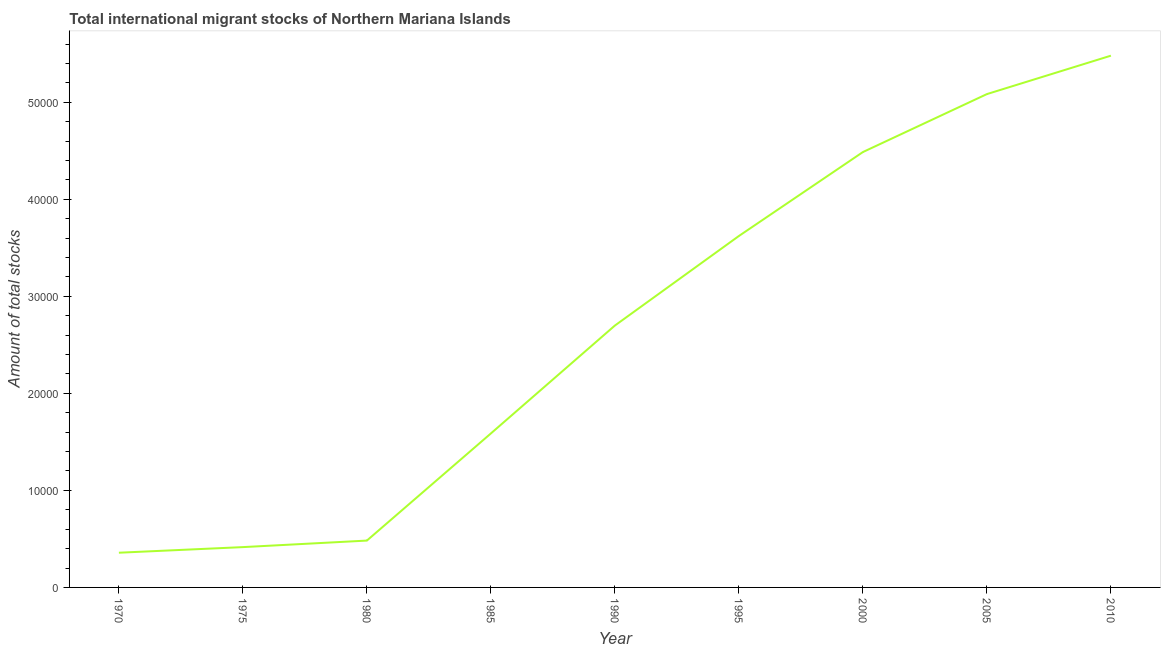What is the total number of international migrant stock in 2005?
Your response must be concise. 5.08e+04. Across all years, what is the maximum total number of international migrant stock?
Give a very brief answer. 5.48e+04. Across all years, what is the minimum total number of international migrant stock?
Your response must be concise. 3576. In which year was the total number of international migrant stock maximum?
Give a very brief answer. 2010. In which year was the total number of international migrant stock minimum?
Ensure brevity in your answer.  1970. What is the sum of the total number of international migrant stock?
Ensure brevity in your answer.  2.42e+05. What is the difference between the total number of international migrant stock in 1980 and 1985?
Your answer should be very brief. -1.10e+04. What is the average total number of international migrant stock per year?
Offer a very short reply. 2.69e+04. What is the median total number of international migrant stock?
Give a very brief answer. 2.70e+04. In how many years, is the total number of international migrant stock greater than 36000 ?
Keep it short and to the point. 4. What is the ratio of the total number of international migrant stock in 1980 to that in 2005?
Offer a very short reply. 0.09. Is the total number of international migrant stock in 1975 less than that in 1980?
Ensure brevity in your answer.  Yes. Is the difference between the total number of international migrant stock in 1995 and 2005 greater than the difference between any two years?
Your answer should be compact. No. What is the difference between the highest and the second highest total number of international migrant stock?
Keep it short and to the point. 3959. What is the difference between the highest and the lowest total number of international migrant stock?
Your response must be concise. 5.12e+04. How many lines are there?
Offer a terse response. 1. How many years are there in the graph?
Offer a terse response. 9. Does the graph contain any zero values?
Give a very brief answer. No. What is the title of the graph?
Your response must be concise. Total international migrant stocks of Northern Mariana Islands. What is the label or title of the Y-axis?
Your answer should be very brief. Amount of total stocks. What is the Amount of total stocks in 1970?
Offer a very short reply. 3576. What is the Amount of total stocks of 1975?
Make the answer very short. 4155. What is the Amount of total stocks in 1980?
Your answer should be compact. 4828. What is the Amount of total stocks in 1985?
Your answer should be compact. 1.59e+04. What is the Amount of total stocks in 1990?
Provide a succinct answer. 2.70e+04. What is the Amount of total stocks of 1995?
Offer a terse response. 3.62e+04. What is the Amount of total stocks in 2000?
Give a very brief answer. 4.49e+04. What is the Amount of total stocks of 2005?
Give a very brief answer. 5.08e+04. What is the Amount of total stocks of 2010?
Offer a terse response. 5.48e+04. What is the difference between the Amount of total stocks in 1970 and 1975?
Keep it short and to the point. -579. What is the difference between the Amount of total stocks in 1970 and 1980?
Offer a terse response. -1252. What is the difference between the Amount of total stocks in 1970 and 1985?
Ensure brevity in your answer.  -1.23e+04. What is the difference between the Amount of total stocks in 1970 and 1990?
Your response must be concise. -2.34e+04. What is the difference between the Amount of total stocks in 1970 and 1995?
Provide a succinct answer. -3.26e+04. What is the difference between the Amount of total stocks in 1970 and 2000?
Keep it short and to the point. -4.13e+04. What is the difference between the Amount of total stocks in 1970 and 2005?
Offer a terse response. -4.73e+04. What is the difference between the Amount of total stocks in 1970 and 2010?
Ensure brevity in your answer.  -5.12e+04. What is the difference between the Amount of total stocks in 1975 and 1980?
Provide a succinct answer. -673. What is the difference between the Amount of total stocks in 1975 and 1985?
Make the answer very short. -1.17e+04. What is the difference between the Amount of total stocks in 1975 and 1990?
Give a very brief answer. -2.28e+04. What is the difference between the Amount of total stocks in 1975 and 1995?
Keep it short and to the point. -3.21e+04. What is the difference between the Amount of total stocks in 1975 and 2000?
Make the answer very short. -4.07e+04. What is the difference between the Amount of total stocks in 1975 and 2005?
Your answer should be very brief. -4.67e+04. What is the difference between the Amount of total stocks in 1975 and 2010?
Provide a succinct answer. -5.06e+04. What is the difference between the Amount of total stocks in 1980 and 1985?
Provide a short and direct response. -1.10e+04. What is the difference between the Amount of total stocks in 1980 and 1990?
Offer a very short reply. -2.22e+04. What is the difference between the Amount of total stocks in 1980 and 1995?
Give a very brief answer. -3.14e+04. What is the difference between the Amount of total stocks in 1980 and 2000?
Offer a very short reply. -4.00e+04. What is the difference between the Amount of total stocks in 1980 and 2005?
Your answer should be compact. -4.60e+04. What is the difference between the Amount of total stocks in 1980 and 2010?
Provide a short and direct response. -5.00e+04. What is the difference between the Amount of total stocks in 1985 and 1990?
Offer a very short reply. -1.11e+04. What is the difference between the Amount of total stocks in 1985 and 1995?
Your answer should be very brief. -2.03e+04. What is the difference between the Amount of total stocks in 1985 and 2000?
Give a very brief answer. -2.90e+04. What is the difference between the Amount of total stocks in 1985 and 2005?
Provide a succinct answer. -3.50e+04. What is the difference between the Amount of total stocks in 1985 and 2010?
Your answer should be very brief. -3.89e+04. What is the difference between the Amount of total stocks in 1990 and 1995?
Your answer should be compact. -9229. What is the difference between the Amount of total stocks in 1990 and 2000?
Your response must be concise. -1.79e+04. What is the difference between the Amount of total stocks in 1990 and 2005?
Provide a short and direct response. -2.39e+04. What is the difference between the Amount of total stocks in 1990 and 2010?
Ensure brevity in your answer.  -2.78e+04. What is the difference between the Amount of total stocks in 1995 and 2000?
Your answer should be very brief. -8649. What is the difference between the Amount of total stocks in 1995 and 2005?
Your answer should be compact. -1.46e+04. What is the difference between the Amount of total stocks in 1995 and 2010?
Provide a short and direct response. -1.86e+04. What is the difference between the Amount of total stocks in 2000 and 2005?
Give a very brief answer. -5973. What is the difference between the Amount of total stocks in 2000 and 2010?
Give a very brief answer. -9932. What is the difference between the Amount of total stocks in 2005 and 2010?
Ensure brevity in your answer.  -3959. What is the ratio of the Amount of total stocks in 1970 to that in 1975?
Offer a very short reply. 0.86. What is the ratio of the Amount of total stocks in 1970 to that in 1980?
Keep it short and to the point. 0.74. What is the ratio of the Amount of total stocks in 1970 to that in 1985?
Provide a short and direct response. 0.23. What is the ratio of the Amount of total stocks in 1970 to that in 1990?
Keep it short and to the point. 0.13. What is the ratio of the Amount of total stocks in 1970 to that in 1995?
Ensure brevity in your answer.  0.1. What is the ratio of the Amount of total stocks in 1970 to that in 2000?
Your response must be concise. 0.08. What is the ratio of the Amount of total stocks in 1970 to that in 2005?
Ensure brevity in your answer.  0.07. What is the ratio of the Amount of total stocks in 1970 to that in 2010?
Give a very brief answer. 0.07. What is the ratio of the Amount of total stocks in 1975 to that in 1980?
Your answer should be very brief. 0.86. What is the ratio of the Amount of total stocks in 1975 to that in 1985?
Offer a very short reply. 0.26. What is the ratio of the Amount of total stocks in 1975 to that in 1990?
Your answer should be very brief. 0.15. What is the ratio of the Amount of total stocks in 1975 to that in 1995?
Offer a very short reply. 0.12. What is the ratio of the Amount of total stocks in 1975 to that in 2000?
Ensure brevity in your answer.  0.09. What is the ratio of the Amount of total stocks in 1975 to that in 2005?
Give a very brief answer. 0.08. What is the ratio of the Amount of total stocks in 1975 to that in 2010?
Ensure brevity in your answer.  0.08. What is the ratio of the Amount of total stocks in 1980 to that in 1985?
Offer a very short reply. 0.3. What is the ratio of the Amount of total stocks in 1980 to that in 1990?
Offer a very short reply. 0.18. What is the ratio of the Amount of total stocks in 1980 to that in 1995?
Your answer should be compact. 0.13. What is the ratio of the Amount of total stocks in 1980 to that in 2000?
Your answer should be very brief. 0.11. What is the ratio of the Amount of total stocks in 1980 to that in 2005?
Your answer should be compact. 0.1. What is the ratio of the Amount of total stocks in 1980 to that in 2010?
Your answer should be compact. 0.09. What is the ratio of the Amount of total stocks in 1985 to that in 1990?
Provide a short and direct response. 0.59. What is the ratio of the Amount of total stocks in 1985 to that in 1995?
Offer a very short reply. 0.44. What is the ratio of the Amount of total stocks in 1985 to that in 2000?
Your answer should be very brief. 0.35. What is the ratio of the Amount of total stocks in 1985 to that in 2005?
Give a very brief answer. 0.31. What is the ratio of the Amount of total stocks in 1985 to that in 2010?
Your answer should be compact. 0.29. What is the ratio of the Amount of total stocks in 1990 to that in 1995?
Provide a succinct answer. 0.74. What is the ratio of the Amount of total stocks in 1990 to that in 2000?
Give a very brief answer. 0.6. What is the ratio of the Amount of total stocks in 1990 to that in 2005?
Your answer should be compact. 0.53. What is the ratio of the Amount of total stocks in 1990 to that in 2010?
Your answer should be compact. 0.49. What is the ratio of the Amount of total stocks in 1995 to that in 2000?
Provide a short and direct response. 0.81. What is the ratio of the Amount of total stocks in 1995 to that in 2005?
Provide a succinct answer. 0.71. What is the ratio of the Amount of total stocks in 1995 to that in 2010?
Your answer should be very brief. 0.66. What is the ratio of the Amount of total stocks in 2000 to that in 2005?
Your answer should be compact. 0.88. What is the ratio of the Amount of total stocks in 2000 to that in 2010?
Provide a short and direct response. 0.82. What is the ratio of the Amount of total stocks in 2005 to that in 2010?
Offer a very short reply. 0.93. 